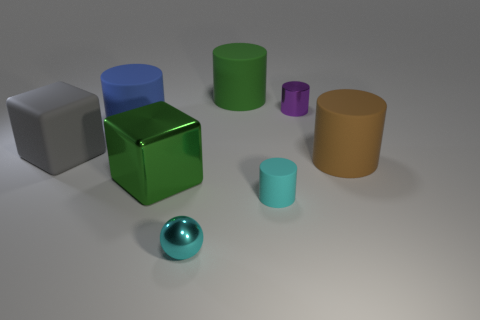Add 2 yellow shiny cubes. How many objects exist? 10 Subtract all big brown matte cylinders. How many cylinders are left? 4 Subtract all blue cylinders. How many cylinders are left? 4 Subtract all brown cylinders. Subtract all big blue cylinders. How many objects are left? 6 Add 5 blue rubber cylinders. How many blue rubber cylinders are left? 6 Add 5 large gray matte cylinders. How many large gray matte cylinders exist? 5 Subtract 0 blue balls. How many objects are left? 8 Subtract all cubes. How many objects are left? 6 Subtract 1 spheres. How many spheres are left? 0 Subtract all green blocks. Subtract all blue cylinders. How many blocks are left? 1 